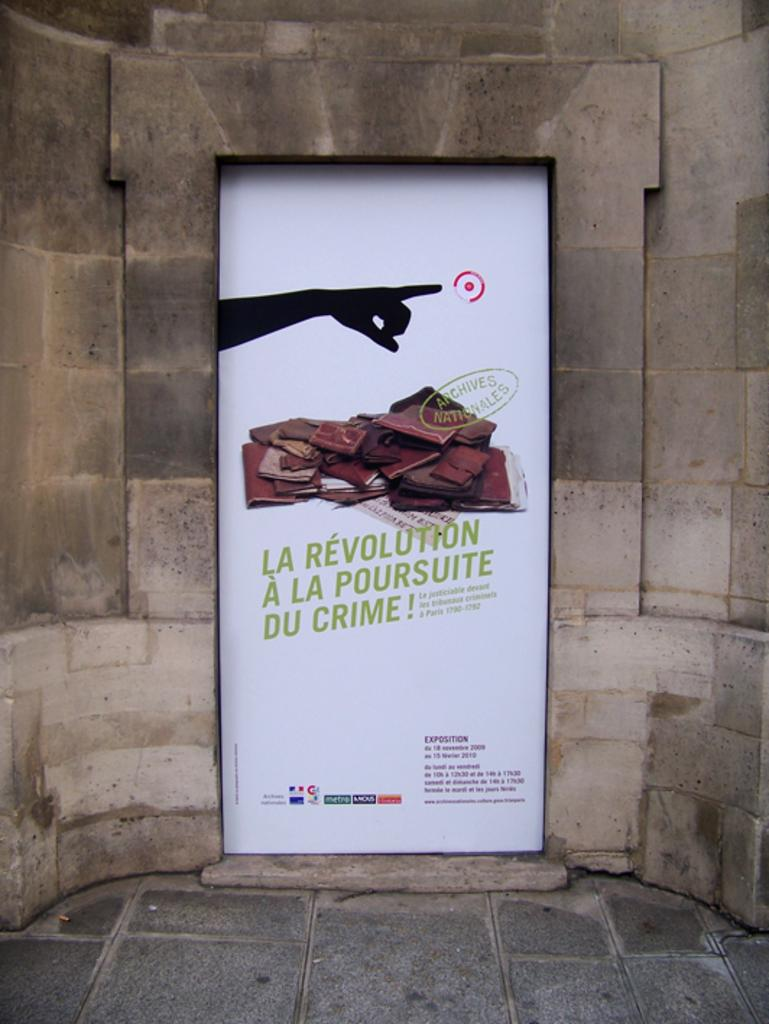<image>
Share a concise interpretation of the image provided. A sign on a concrete block wall says la revolution on it in green letters. 